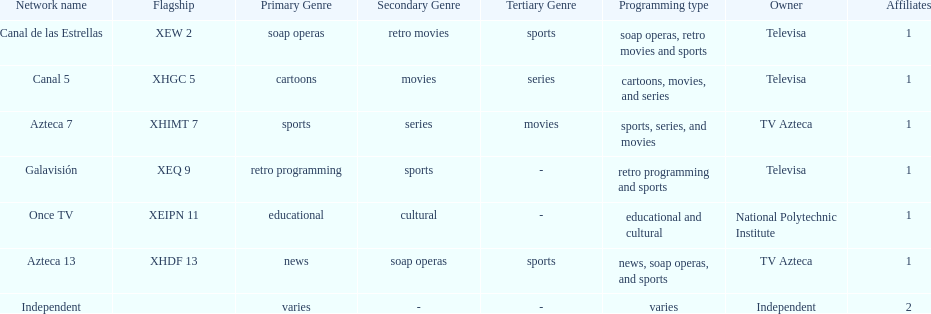What is the difference between the number of affiliates galavision has and the number of affiliates azteca 13 has? 0. 